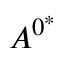<formula> <loc_0><loc_0><loc_500><loc_500>A ^ { 0 ^ { * } }</formula> 